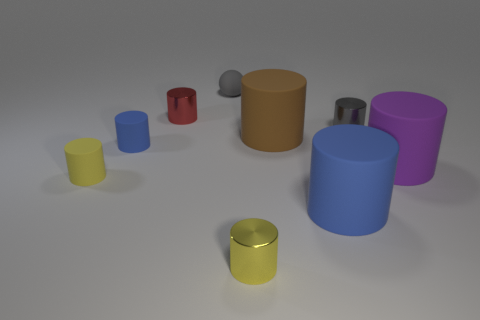There is a yellow thing that is right of the red cylinder; is it the same size as the purple matte object?
Offer a very short reply. No. What shape is the gray object to the left of the large thing that is behind the big purple matte thing?
Offer a terse response. Sphere. What size is the metal thing that is on the right side of the brown matte object behind the purple thing?
Your answer should be very brief. Small. There is a big rubber thing behind the purple rubber cylinder; what is its color?
Provide a succinct answer. Brown. There is a yellow cylinder that is made of the same material as the brown thing; what is its size?
Provide a succinct answer. Small. How many tiny red metallic objects are the same shape as the gray shiny thing?
Your response must be concise. 1. What is the material of the blue object that is the same size as the red metal cylinder?
Keep it short and to the point. Rubber. Are there any tiny gray things that have the same material as the large brown thing?
Offer a very short reply. Yes. What is the color of the small thing that is behind the small yellow metal cylinder and in front of the small blue rubber object?
Keep it short and to the point. Yellow. How many other objects are the same color as the rubber sphere?
Keep it short and to the point. 1. 